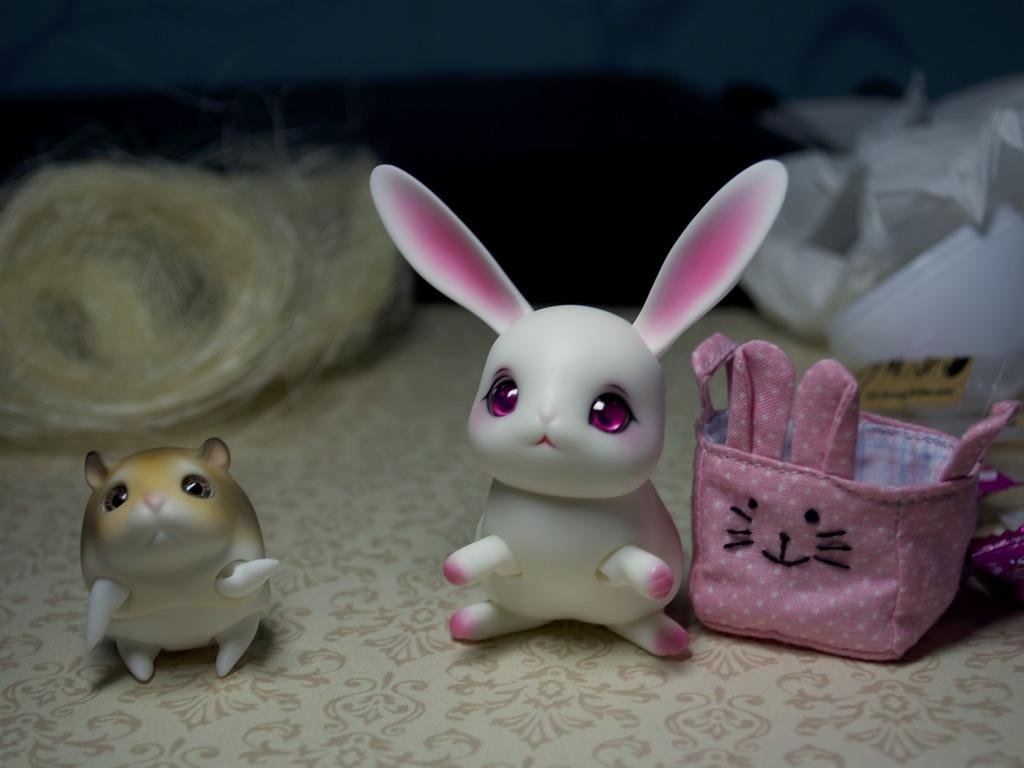What type of furniture is present in the image? There is a table in the image. What items can be seen on the table? There are toys, a purse, and ropes on the table. What type of border is visible around the toys on the table? There is no border visible around the toys on the table; the toys are simply placed on the table. 